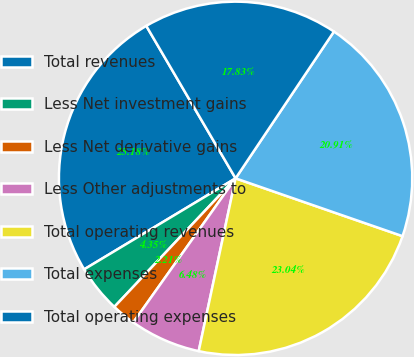<chart> <loc_0><loc_0><loc_500><loc_500><pie_chart><fcel>Total revenues<fcel>Less Net investment gains<fcel>Less Net derivative gains<fcel>Less Other adjustments to<fcel>Total operating revenues<fcel>Total expenses<fcel>Total operating expenses<nl><fcel>25.18%<fcel>4.35%<fcel>2.21%<fcel>6.48%<fcel>23.04%<fcel>20.91%<fcel>17.83%<nl></chart> 